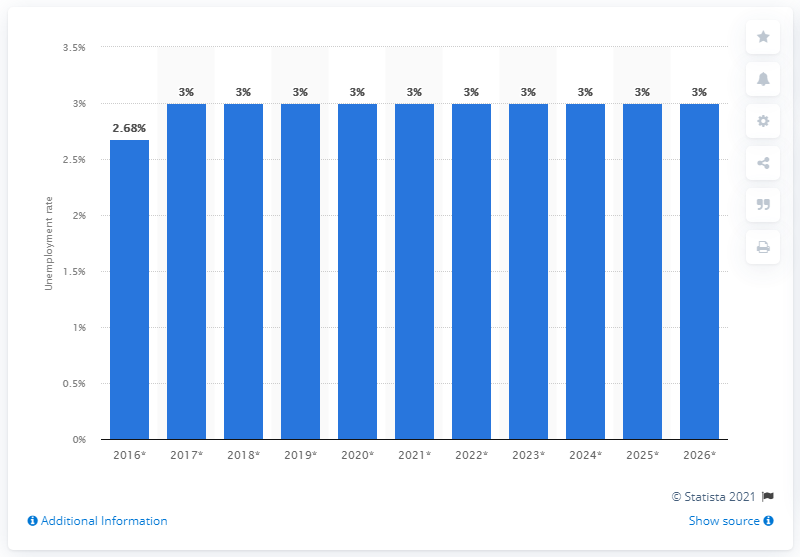Mention a couple of crucial points in this snapshot. The unemployment rate in the Seychelles was 3% in 2020. 